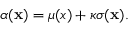Convert formula to latex. <formula><loc_0><loc_0><loc_500><loc_500>\begin{array} { r } { \alpha ( x ) = \mu ( { x } ) + \kappa \sigma ( x ) . } \end{array}</formula> 